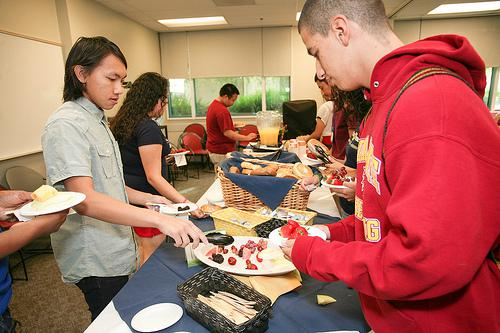Question: what color are the tablecloths?
Choices:
A. Yellow.
B. Black.
C. Blue.
D. Red.
Answer with the letter. Answer: C Question: why are these people gathered?
Choices:
A. For a wedding.
B. For a buffet.
C. For a birthday party.
D. For a family reunion.
Answer with the letter. Answer: B Question: where is a wipe board hanging?
Choices:
A. By the entryway.
B. By the refridgerator.
C. By the desk.
D. On the left wall.
Answer with the letter. Answer: D Question: what is on the back wall?
Choices:
A. Pictures.
B. Cabinets.
C. Windows.
D. Artwork.
Answer with the letter. Answer: C 